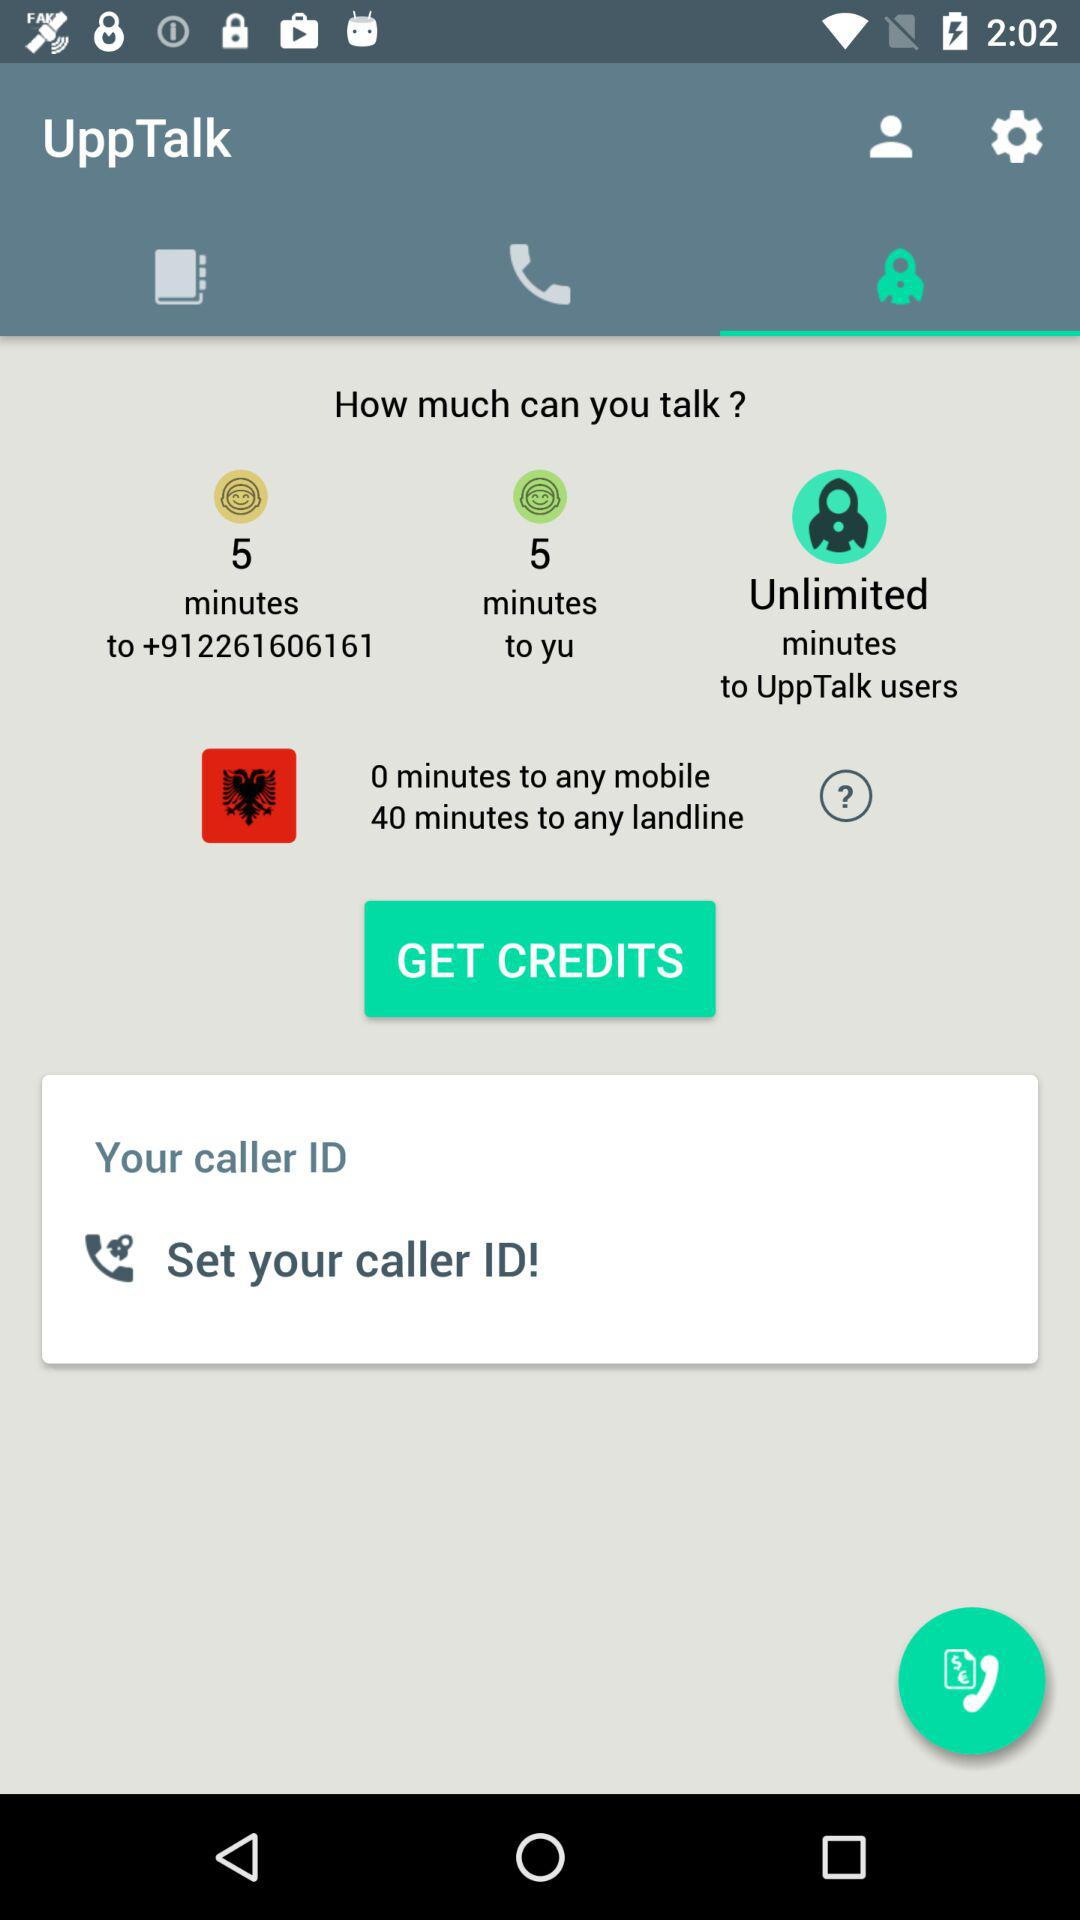For how many minutes can we talk to any mobile user? You can talk to any mobile user for 0 minutes. 